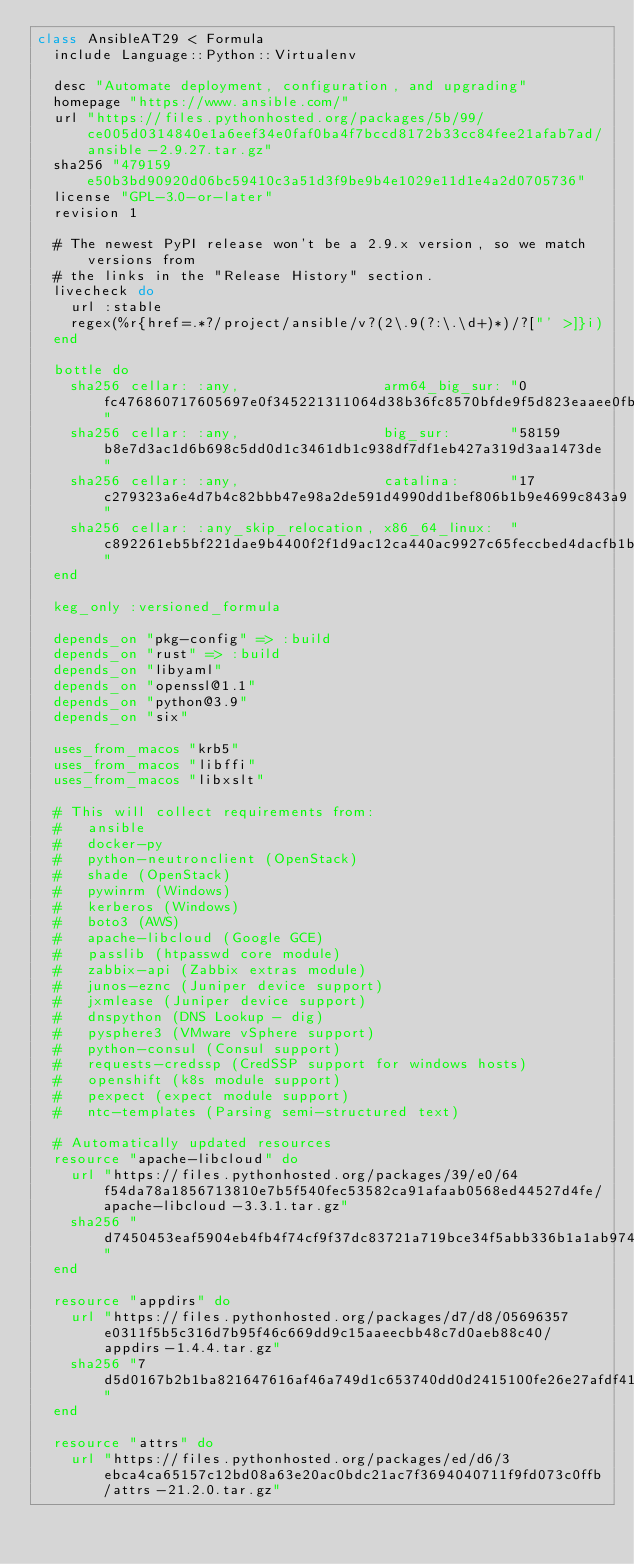Convert code to text. <code><loc_0><loc_0><loc_500><loc_500><_Ruby_>class AnsibleAT29 < Formula
  include Language::Python::Virtualenv

  desc "Automate deployment, configuration, and upgrading"
  homepage "https://www.ansible.com/"
  url "https://files.pythonhosted.org/packages/5b/99/ce005d0314840e1a6eef34e0faf0ba4f7bccd8172b33cc84fee21afab7ad/ansible-2.9.27.tar.gz"
  sha256 "479159e50b3bd90920d06bc59410c3a51d3f9be9b4e1029e11d1e4a2d0705736"
  license "GPL-3.0-or-later"
  revision 1

  # The newest PyPI release won't be a 2.9.x version, so we match versions from
  # the links in the "Release History" section.
  livecheck do
    url :stable
    regex(%r{href=.*?/project/ansible/v?(2\.9(?:\.\d+)*)/?["' >]}i)
  end

  bottle do
    sha256 cellar: :any,                 arm64_big_sur: "0fc476860717605697e0f345221311064d38b36fc8570bfde9f5d823eaaee0fb"
    sha256 cellar: :any,                 big_sur:       "58159b8e7d3ac1d6b698c5dd0d1c3461db1c938df7df1eb427a319d3aa1473de"
    sha256 cellar: :any,                 catalina:      "17c279323a6e4d7b4c82bbb47e98a2de591d4990dd1bef806b1b9e4699c843a9"
    sha256 cellar: :any_skip_relocation, x86_64_linux:  "c892261eb5bf221dae9b4400f2f1d9ac12ca440ac9927c65feccbed4dacfb1bd"
  end

  keg_only :versioned_formula

  depends_on "pkg-config" => :build
  depends_on "rust" => :build
  depends_on "libyaml"
  depends_on "openssl@1.1"
  depends_on "python@3.9"
  depends_on "six"

  uses_from_macos "krb5"
  uses_from_macos "libffi"
  uses_from_macos "libxslt"

  # This will collect requirements from:
  #   ansible
  #   docker-py
  #   python-neutronclient (OpenStack)
  #   shade (OpenStack)
  #   pywinrm (Windows)
  #   kerberos (Windows)
  #   boto3 (AWS)
  #   apache-libcloud (Google GCE)
  #   passlib (htpasswd core module)
  #   zabbix-api (Zabbix extras module)
  #   junos-eznc (Juniper device support)
  #   jxmlease (Juniper device support)
  #   dnspython (DNS Lookup - dig)
  #   pysphere3 (VMware vSphere support)
  #   python-consul (Consul support)
  #   requests-credssp (CredSSP support for windows hosts)
  #   openshift (k8s module support)
  #   pexpect (expect module support)
  #   ntc-templates (Parsing semi-structured text)

  # Automatically updated resources
  resource "apache-libcloud" do
    url "https://files.pythonhosted.org/packages/39/e0/64f54da78a1856713810e7b5f540fec53582ca91afaab0568ed44527d4fe/apache-libcloud-3.3.1.tar.gz"
    sha256 "d7450453eaf5904eb4fb4f74cf9f37dc83721a719bce34f5abb336b1a1ab974d"
  end

  resource "appdirs" do
    url "https://files.pythonhosted.org/packages/d7/d8/05696357e0311f5b5c316d7b95f46c669dd9c15aaeecbb48c7d0aeb88c40/appdirs-1.4.4.tar.gz"
    sha256 "7d5d0167b2b1ba821647616af46a749d1c653740dd0d2415100fe26e27afdf41"
  end

  resource "attrs" do
    url "https://files.pythonhosted.org/packages/ed/d6/3ebca4ca65157c12bd08a63e20ac0bdc21ac7f3694040711f9fd073c0ffb/attrs-21.2.0.tar.gz"</code> 